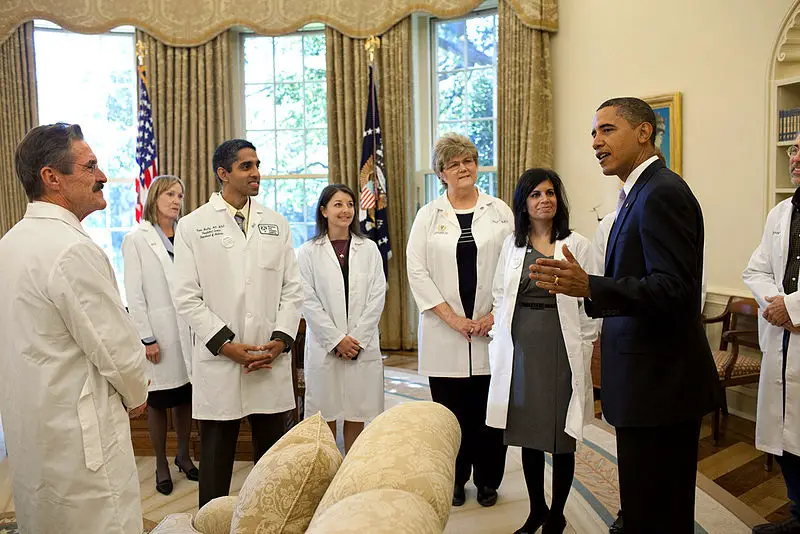What might be the possible topics being discussed in this meeting, and why do you think so? Based on the presence of medical professionals and the formal setting, possible topics of discussion could include public health policies, advancements in medical research, or responses to ongoing health crises. The involvement of an individual in a suit, likely a government official, indicates that these discussions could influence national or regional healthcare strategies, public safety measures, or the implementation of new medical programs. What are the potential implications of such discussions for the general public? The implications of these high-level discussions can be significant for the general public. Potential outcomes may include the introduction of new healthcare policies, enhancement of public health initiatives, better access to medical treatments, or improved preparedness for health emergencies. These initiatives can lead to improved health outcomes, more efficient healthcare delivery, and greater public awareness about health issues. 